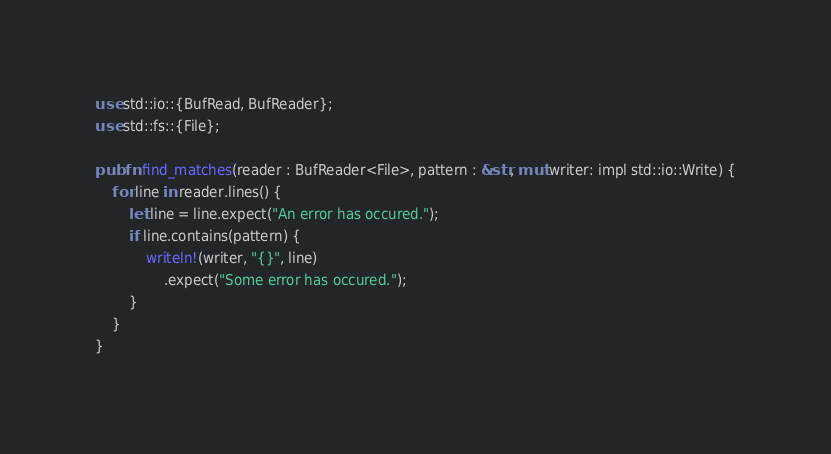Convert code to text. <code><loc_0><loc_0><loc_500><loc_500><_Rust_>use std::io::{BufRead, BufReader};
use std::fs::{File};

pub fn find_matches(reader : BufReader<File>, pattern : &str, mut writer: impl std::io::Write) {
    for line in reader.lines() {
        let line = line.expect("An error has occured.");
        if line.contains(pattern) {
            writeln!(writer, "{}", line)
                .expect("Some error has occured.");
        }
    }
}</code> 